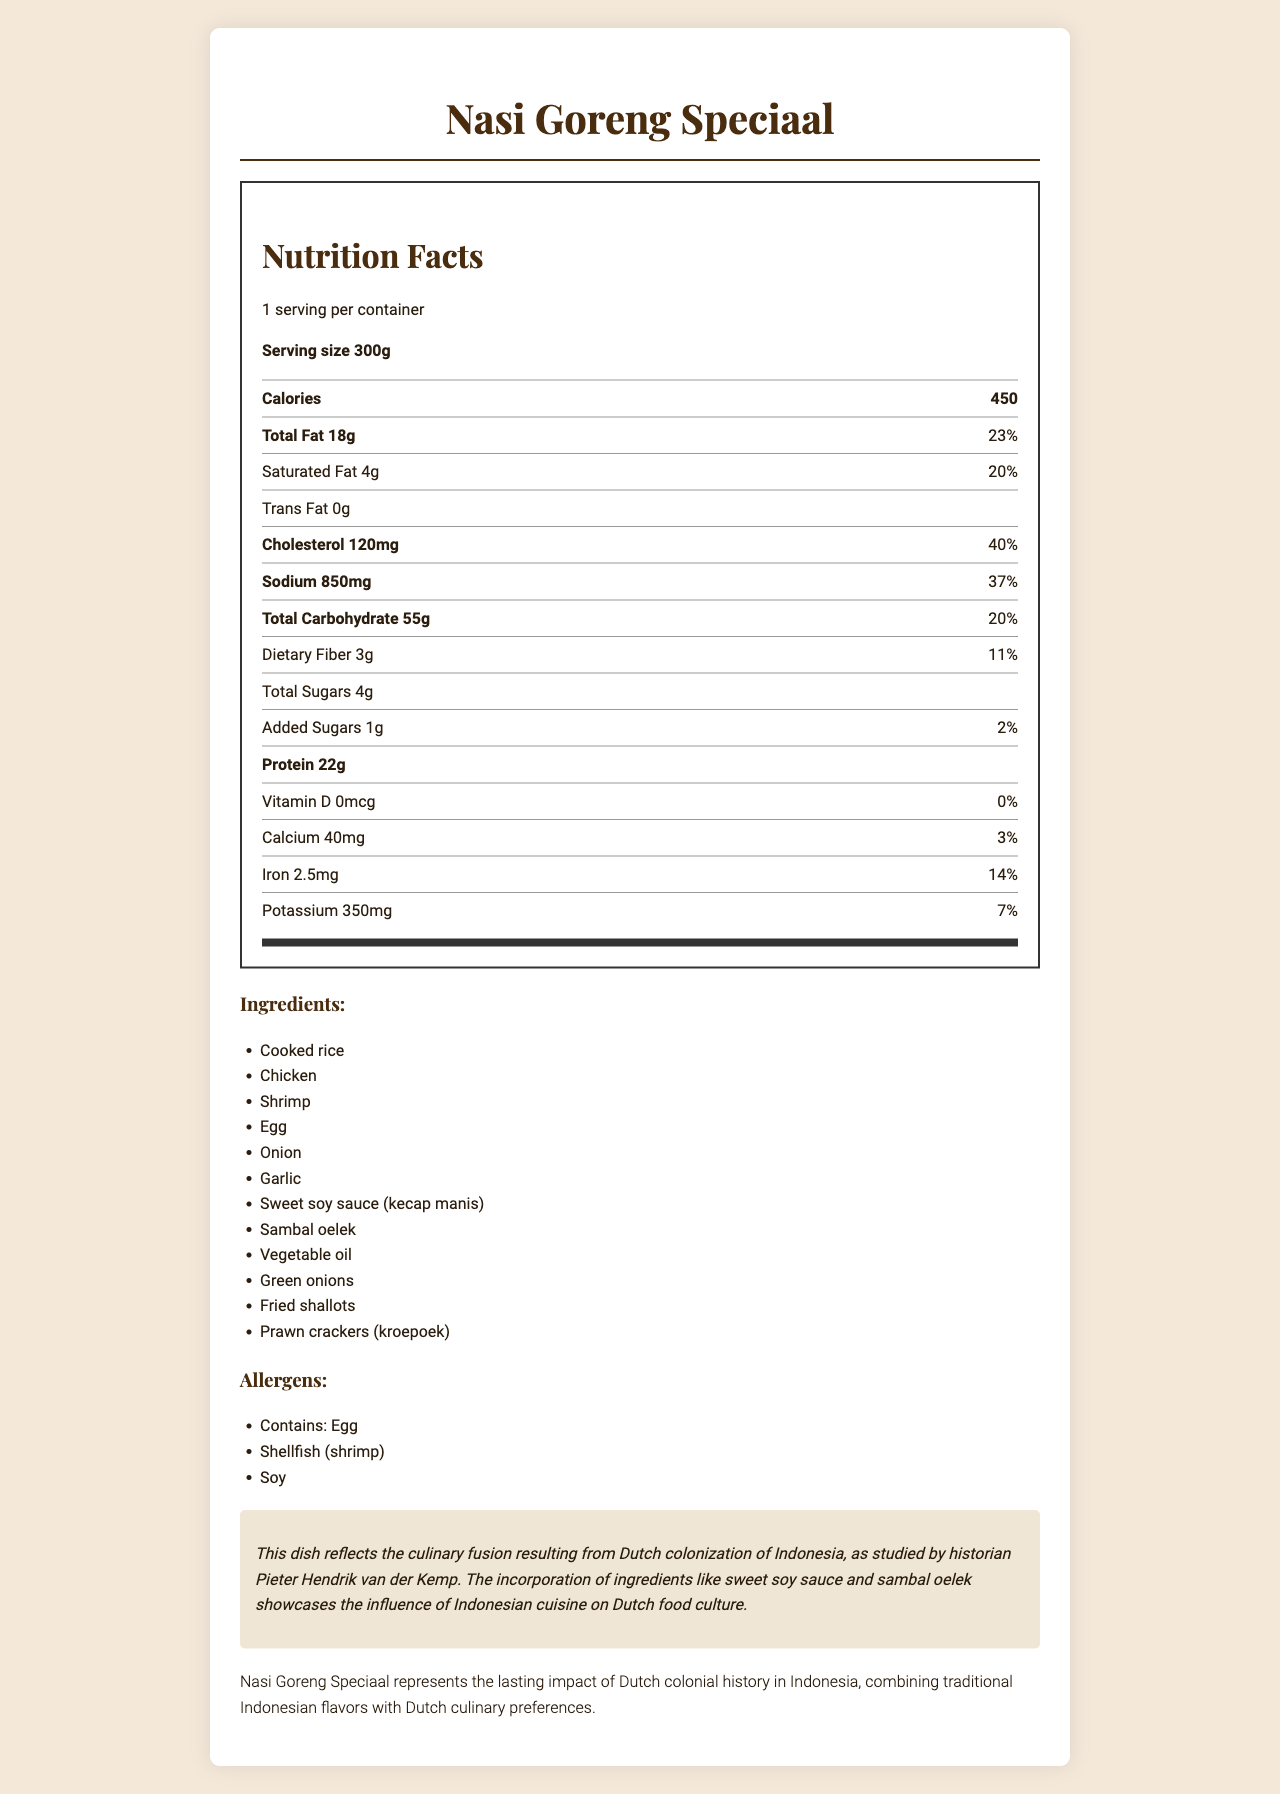what is the serving size? The document lists the serving size as 300g next to the header "Serving size".
Answer: 300g how many calories are in one serving? The number of calories is indicated as 450 within the nutrition facts section under the header "Calories".
Answer: 450 how much iron does one serving provide in milligrams? The nutrition label states the amount of iron as 2.5mg.
Answer: 2.5mg what is the daily value percentage for total fat? The document shows that the daily value percentage for total fat is 23%.
Answer: 23% how many grams of protein does one serving contain? The document specifies that there are 22 grams of protein per serving.
Answer: 22g which allergen is NOT listed for "Nasi Goreng Speciaal"? A. Egg B. Shellfish (shrimp) C. Soy D. Peanut The list of allergens mentions Egg, Shellfish (shrimp), and Soy, but does not include Peanut.
Answer: D. Peanut what is the amount of dietary fiber in one serving? The amount of dietary fiber per serving is listed as 3g in the nutrition facts section.
Answer: 3g which micronutrient has a daily value percentage of 0%? A. Calcium B. Iron C. Potassium D. Vitamin D The nutrition facts section indicates that Vitamin D has a daily value percentage of 0%.
Answer: D. Vitamin D does "Nasi Goreng Speciaal" contain added sugars? The document specifies that it has 1g of added sugars, confirmed by "Added Sugars 1g".
Answer: Yes what is the main idea of the document? The document includes detailed nutrition facts, ingredient and allergen lists, and notes on the dish's historical and cultural significance.
Answer: The document provides nutritional information, ingredients, allergens, and historical and cultural context for "Nasi Goreng Speciaal", a Dutch-Indonesian fusion dish. what preparation method is used for "Nasi Goreng Speciaal"? The document states that the preparation method for this dish is stir-fried.
Answer: Stir-fried how much cholesterol does one serving contain? According to the nutrition facts, one serving contains 120mg of cholesterol.
Answer: 120mg which of the following cities is NOT listed as a popular region for this dish? A. Amsterdam B. Rotterdam C. Groningen D. Utrecht The document lists Amsterdam, Rotterdam, The Hague, and Utrecht as popular regions, but not Groningen.
Answer: C. Groningen does the nutritional label provide information on Vitamin C content? The document does not mention Vitamin C content, focusing instead on other nutrients like Vitamin D, Calcium, Iron, and Potassium.
Answer: No what is the historical significance of "Nasi Goreng Speciaal"? The historical note explains that the dish showcases the influence of Indonesian cuisine on Dutch food culture due to colonization.
Answer: Nasi Goreng Speciaal reflects the culinary fusion resulting from Dutch colonization of Indonesia, incorporating Indonesian flavors into Dutch cuisine. what is the total carbohydrate content in one serving? The document lists the total carbohydrate content as 55g in the nutrition facts section.
Answer: 55g what type of oil is used in "Nasi Goreng Speciaal"? The ingredient list includes vegetable oil as one of the components of the dish.
Answer: Vegetable oil what unique ingredients give "Nasi Goreng Speciaal" its specific flavors? A. Shrimp and Prawn crackers B. Rice and Chicken C. Sweet soy sauce and Sambal oelek D. Egg and Onions The historical note mentions that the incorporation of sweet soy sauce and sambal oelek reflects the Indonesian influence on this dish.
Answer: C. Sweet soy sauce and Sambal oelek what are the main allergens present in "Nasi Goreng Speciaal"? The allergens section of the document lists Egg, Shellfish (shrimp), and Soy as present in the dish.
Answer: Egg, Shellfish (shrimp), Soy how many milligrams of sodium are in one serving? The nutrition label specifies that there are 850mg of sodium in one serving.
Answer: 850mg is the preparation method for "Nasi Goreng Speciaal" mentioned in the document? The document mentions that the preparation method of this dish is stir-fried, indicated under "preparation_method".
Answer: Yes what is the significance of fried shallots in "Nasi Goreng Speciaal"? The document lists fried shallots as an ingredient but does not provide specific information on their significance.
Answer: Not enough information 